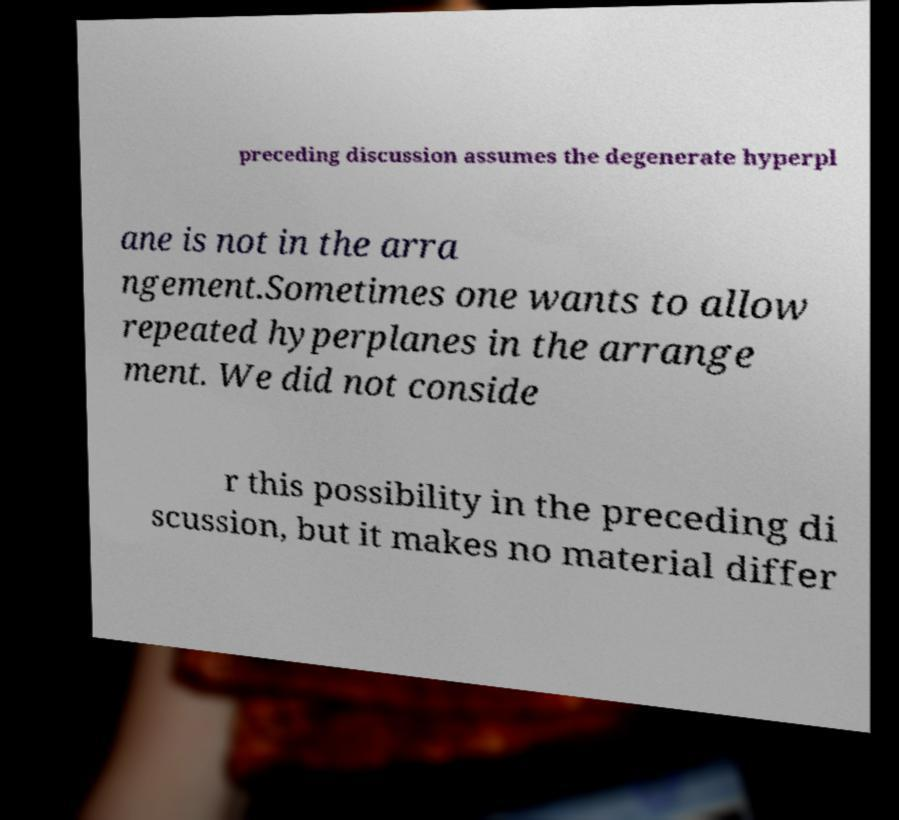Please identify and transcribe the text found in this image. preceding discussion assumes the degenerate hyperpl ane is not in the arra ngement.Sometimes one wants to allow repeated hyperplanes in the arrange ment. We did not conside r this possibility in the preceding di scussion, but it makes no material differ 